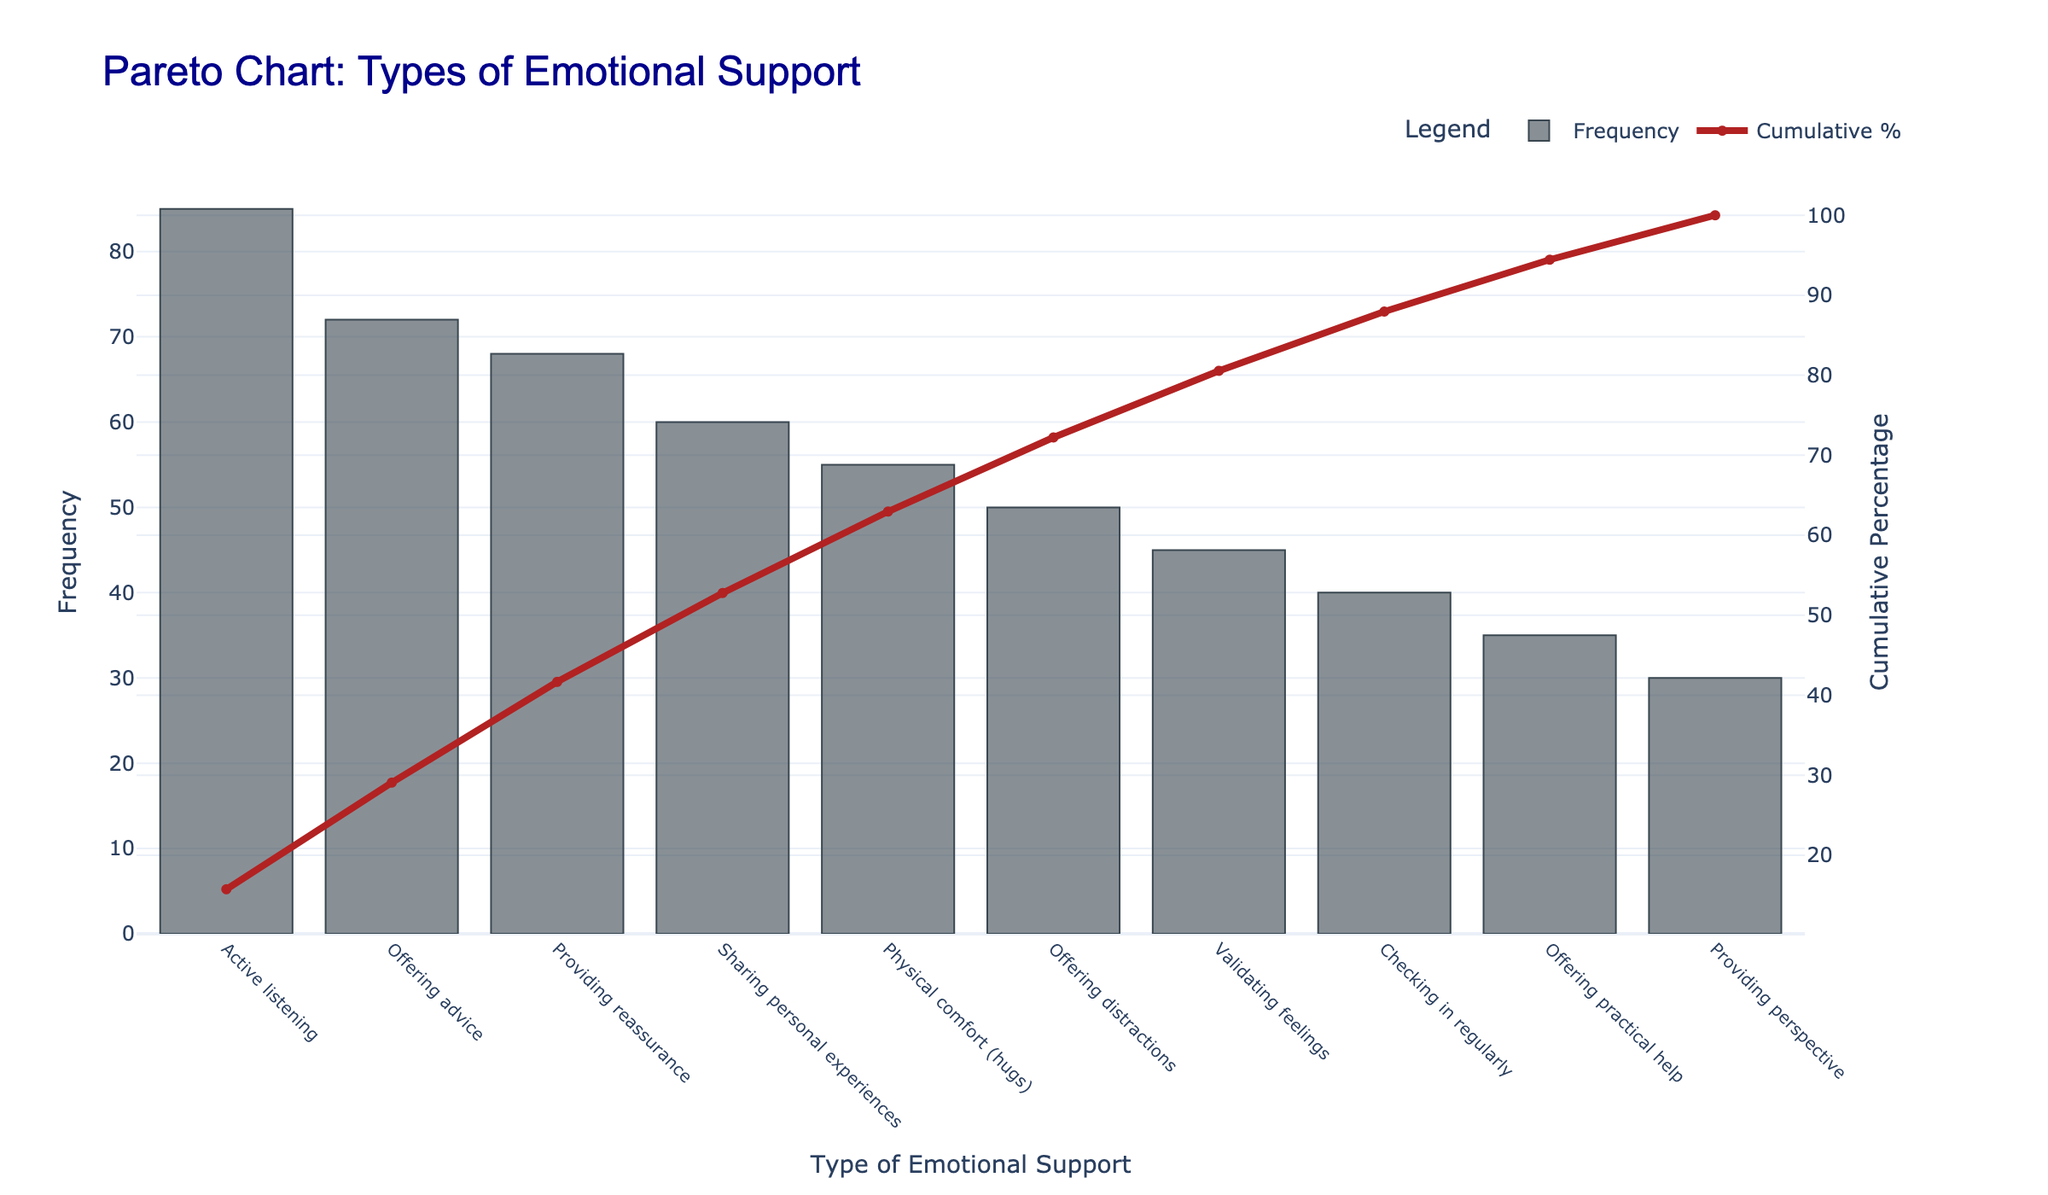what is the title of the chart? To find the title, look at the top center of the chart. It's typically displayed prominently and describes what the chart is about. The title here states the focus of the chart.
Answer: Pareto Chart: Types of Emotional Support How many types of emotional support are listed in the chart? Count the unique labels on the x-axis that represent different types of emotional support.
Answer: 10 Which type of emotional support has the highest frequency? Look for the tallest bar on the chart, which corresponds to the highest frequency value.
Answer: Active listening What percentage of cumulative frequency does validating feelings contribute? Trace the point on the cumulative percentage line that aligns with the bar for validating feelings, then note the percentage on the secondary y-axis.
Answer: 83% What is the difference in frequency between the most common and least common types of emotional support? Find the frequency of the most common type (Active listening) and the least common type (Providing perspective), then subtract the lesser value from the greater value.
Answer: 55 Which types of emotional support have a frequency of 50 or less? Look for bars that are shorter than or equal to the height corresponding to a frequency of 50 on the primary y-axis. The types that meet this criterion are at or above that height.
Answer: Offering distractions, Validating feelings, Checking in regularly, Offering practical help, Providing perspective How does the frequency of offering advice compare to providing reassurance? Compare the heights of the bars for offering advice and providing reassurance. Both height and numerical values can be compared directly here.
Answer: Offering advice has a higher frequency Which emotional support, despite its lower frequency, has a high effectiveness score? Look for types of emotional support with lower bars (lower frequency) that still have high numerical values in effectiveness (physical comfort, validating feelings).
Answer: Physical comfort How much cumulative percentage is reached by including the top three types of emotional support? Sum the percentages contributed by the top three types of emotional support (Active listening, Offering advice, Providing reassurance). These percentages can be read from the cumulative percentage line at the bars corresponding to these types.
Answer: 70% Which emotional support type's frequency causes the cumulative percentage to exceed 90%? Find the exact point on the cumulative line where it surpasses 90%. Trace vertically down to find the type of emotional support corresponding to this value.
Answer: Offering practical help 